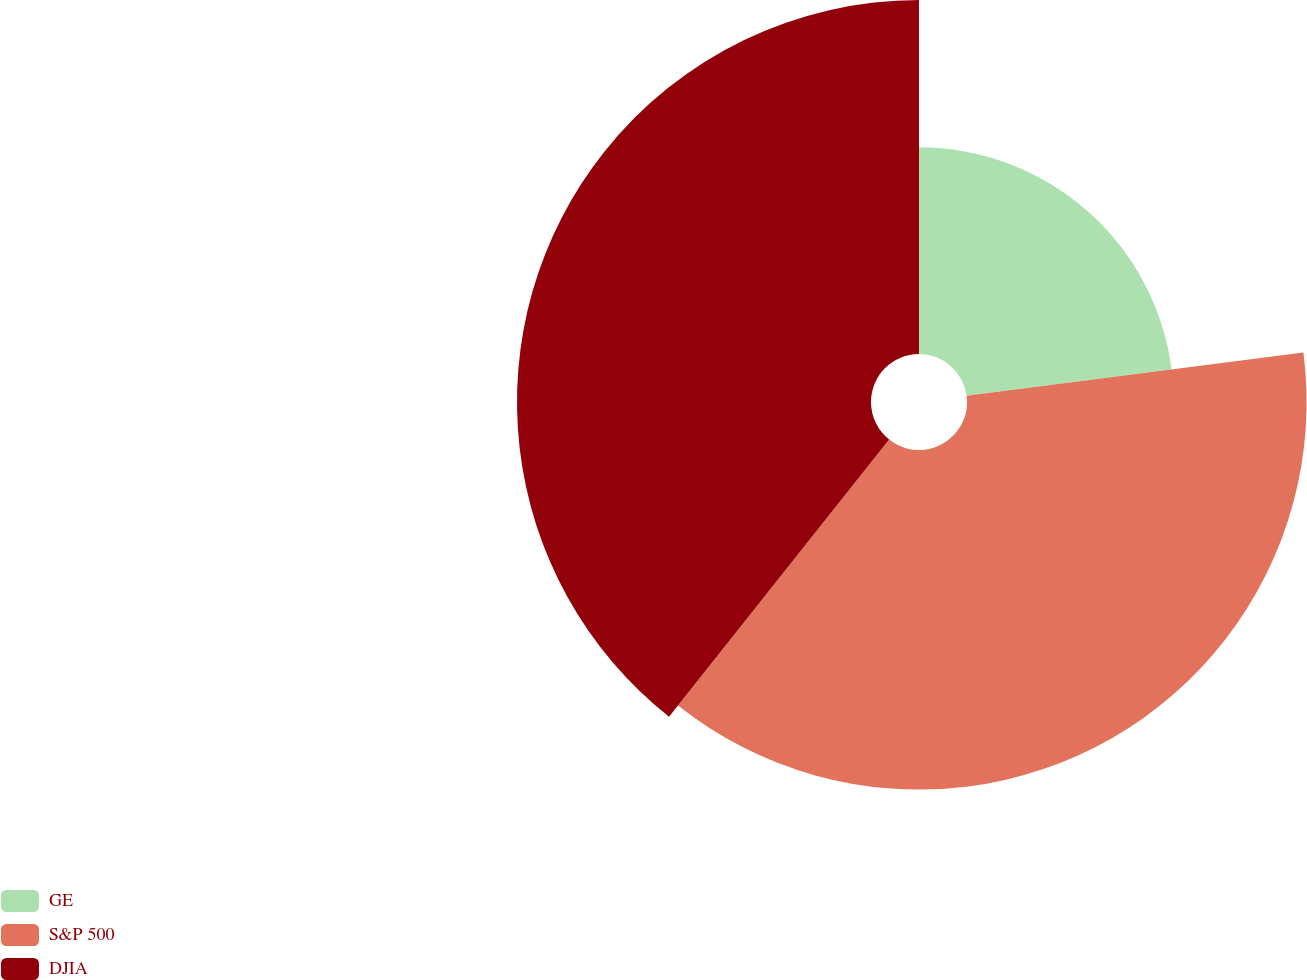<chart> <loc_0><loc_0><loc_500><loc_500><pie_chart><fcel>GE<fcel>S&P 500<fcel>DJIA<nl><fcel>22.96%<fcel>37.72%<fcel>39.32%<nl></chart> 